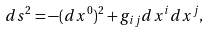Convert formula to latex. <formula><loc_0><loc_0><loc_500><loc_500>d s ^ { 2 } = - ( d x ^ { 0 } ) ^ { 2 } + g _ { i j } d x ^ { i } d x ^ { j } ,</formula> 